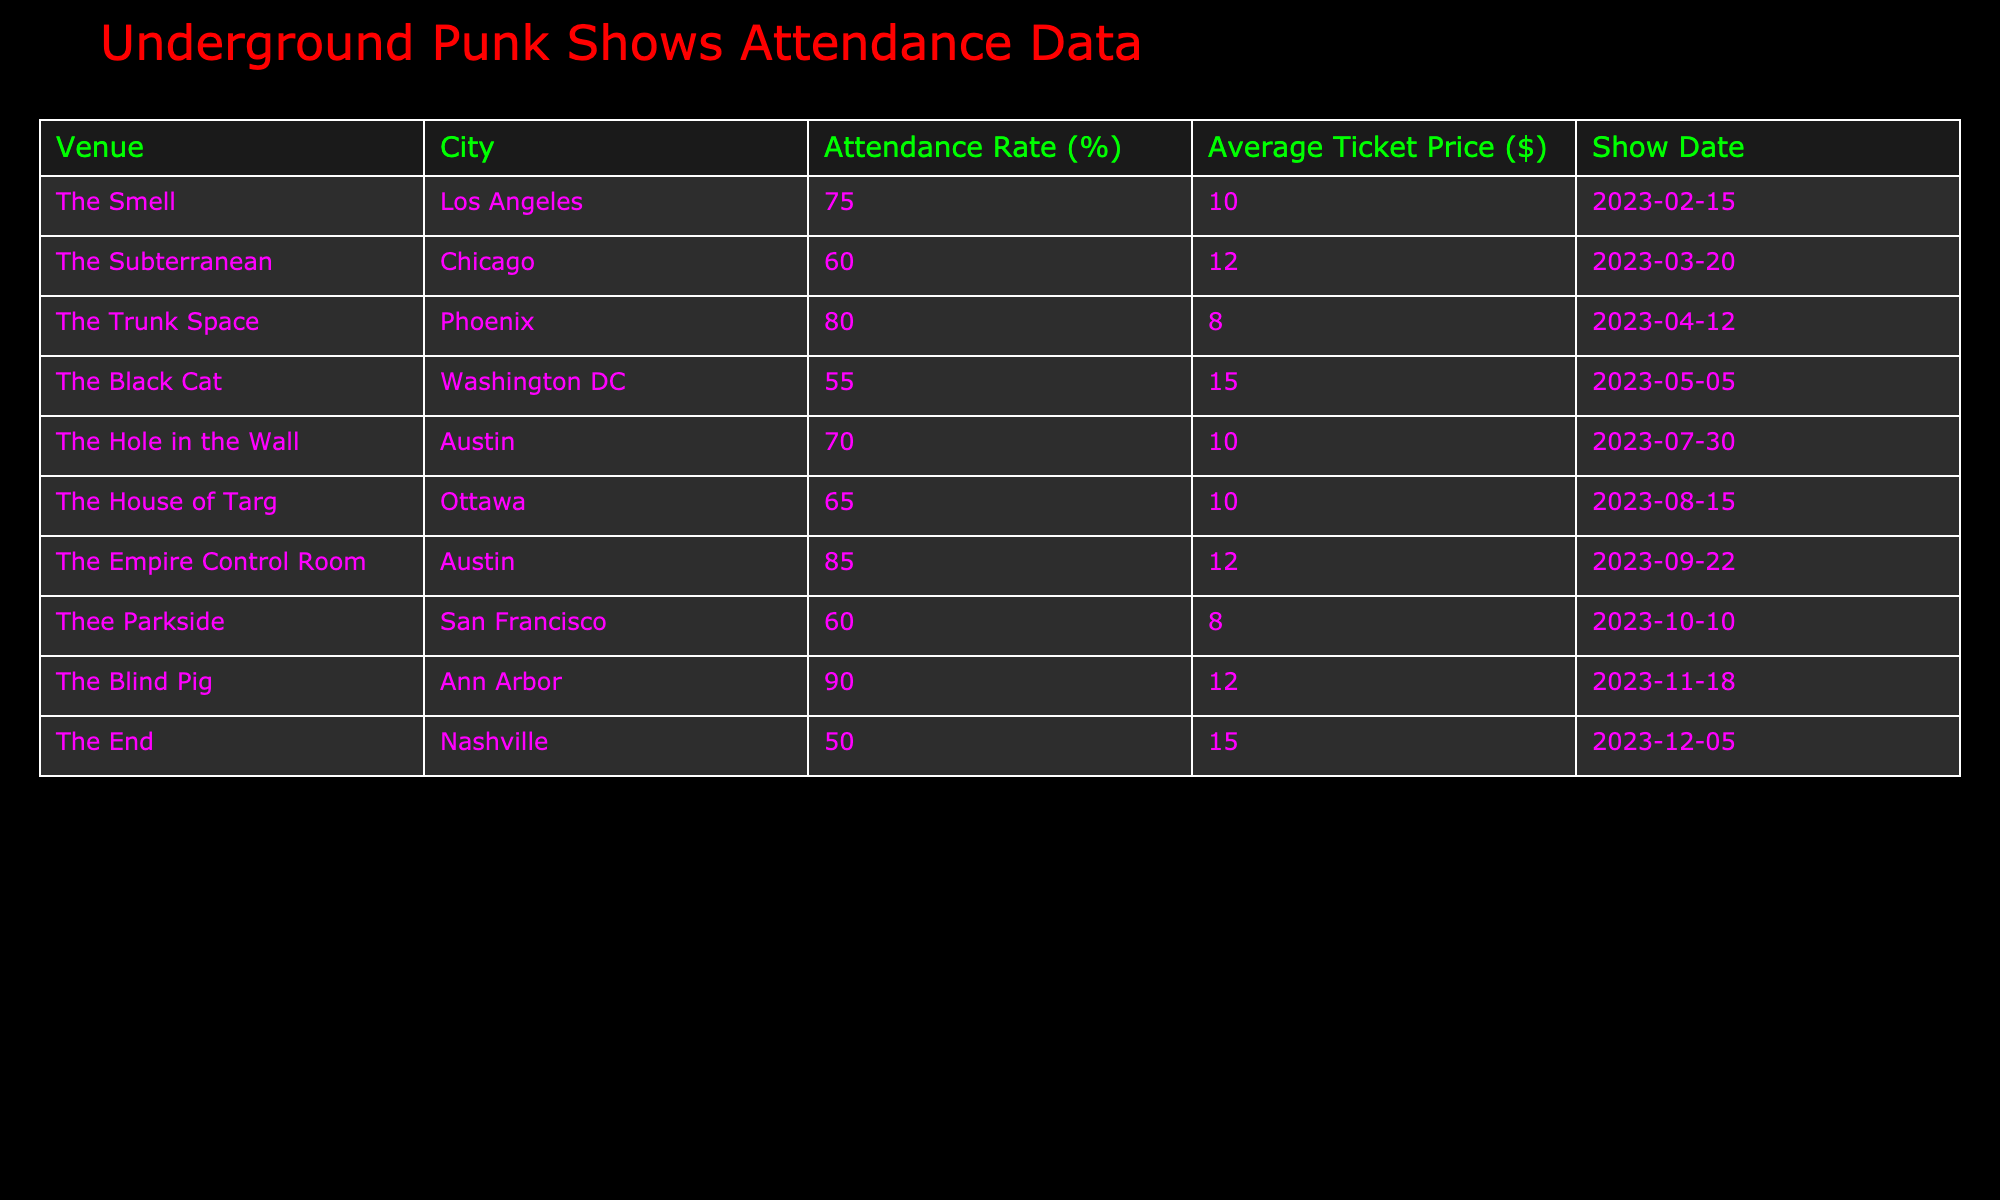What's the highest attendance rate recorded? The highest attendance rate in the table is 90%, which is associated with The Blind Pig in Ann Arbor on November 18, 2023.
Answer: 90% Which venue had the lowest attendance rate? The lowest attendance rate listed is 50%, recorded at The End in Nashville on December 5, 2023.
Answer: 50% What is the average ticket price for shows in Austin? There are two shows in Austin: The Hole in the Wall with a ticket price of $10 and The Empire Control Room with $12. To find the average, add the two prices (10 + 12 = 22) and divide by 2, giving an average of $11.
Answer: $11 Is The Smell in Los Angeles the only venue with an attendance rate above 70%? No, there are three venues with attendance rates above 70%: The Trunk Space (80%), The Empire Control Room (85%), and The Blind Pig (90%).
Answer: No What would be the total attendance rate for venues located in cities starting with the letter "A"? The cities that start with "A" are Austin. The venues there are The Hole in the Wall (70%) and The Empire Control Room (85%). To find the total attendance rate, we sum these two rates (70 + 85 = 155) and note that there are 2 venues. The average attendance rate is therefore 155 / 2 = 77.5%.
Answer: 77.5% How many venues had an attendance rate lower than 65%? According to the table, the venues with attendance rates below 65% are The Black Cat (55%) and The End (50%). Therefore, there are 2 venues that meet this criterion.
Answer: 2 What is the overall average attendance rate across all venues? To calculate the overall average attendance rate, add all the attendance rates listed (75 + 60 + 80 + 55 + 70 + 65 + 85 + 60 + 90 + 50 =  750) and divide by the total number of venues (10). This results in an average of 750 / 10 = 75%.
Answer: 75% Which city had a venue with an average ticket price highest than $12? The Black Cat in Washington DC has an average ticket price of $15, which is higher than $12. The End in Nashville also has an average ticket price of $15. Thus, cities with venues exceeding $12 in ticket price are Washington DC and Nashville.
Answer: Washington DC, Nashville Was there a show in Phoenix with an attendance rate higher than 75%? Yes, The Empire Control Room in Austin had an attendance rate of 85%, and while it's not in Phoenix, The Trunk Space in Phoenix had an attendance rate of 80%, which is higher than 75%.
Answer: Yes 